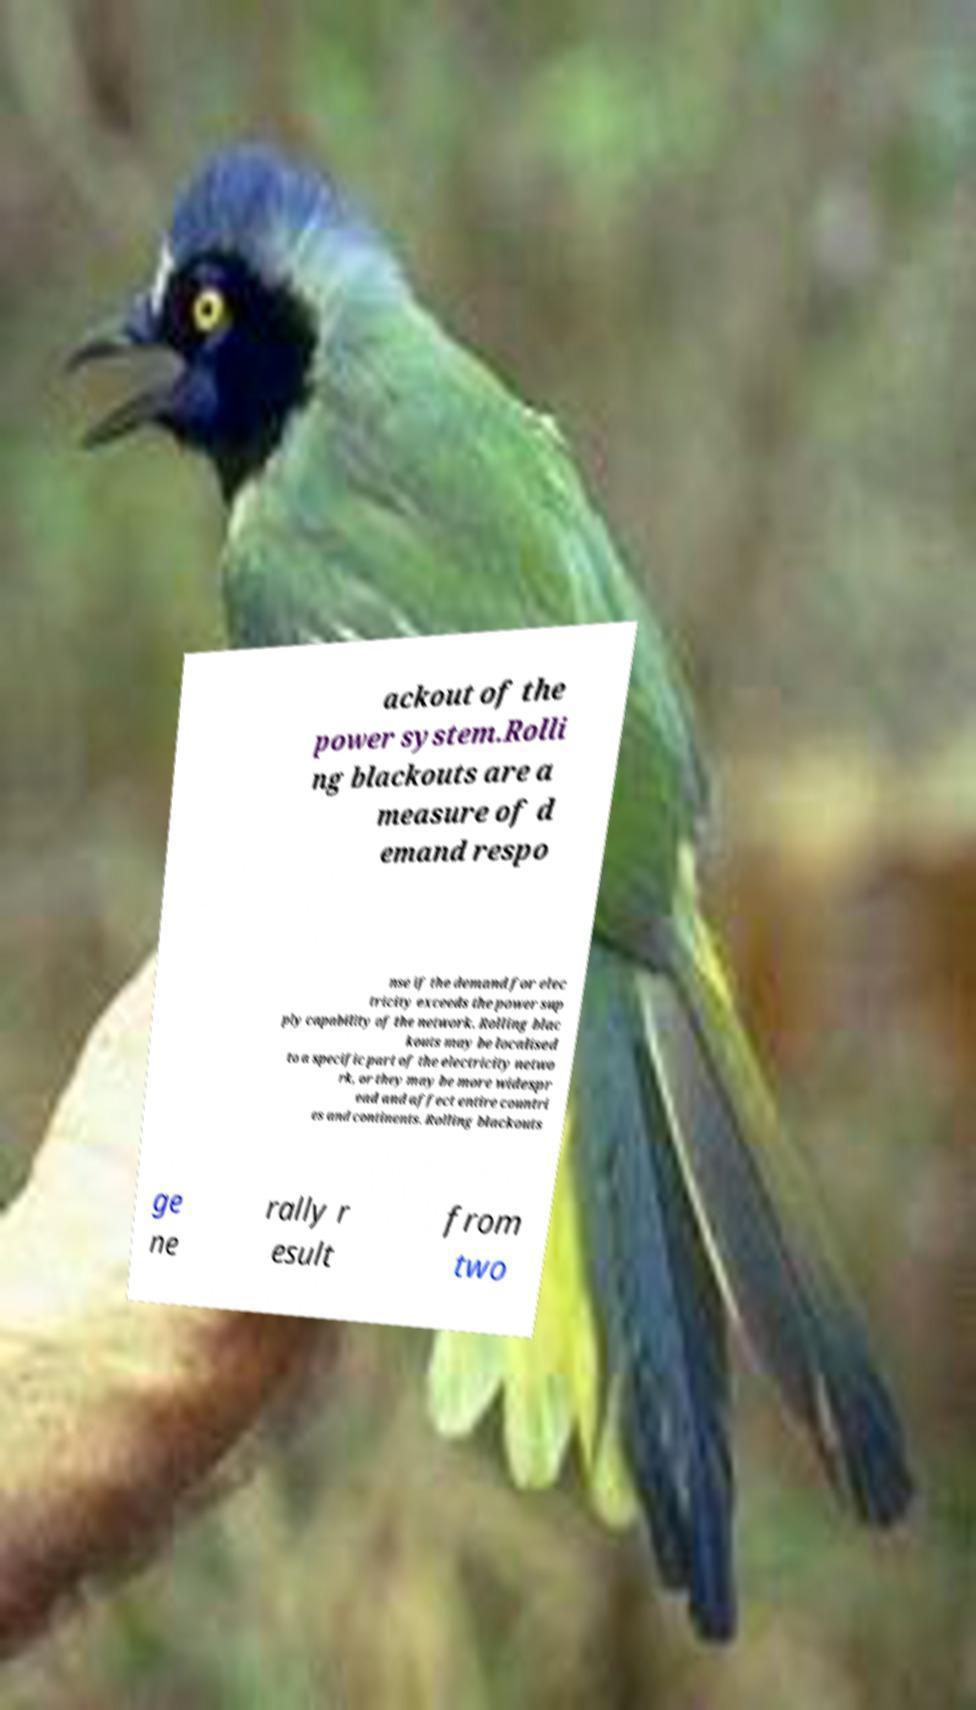For documentation purposes, I need the text within this image transcribed. Could you provide that? ackout of the power system.Rolli ng blackouts are a measure of d emand respo nse if the demand for elec tricity exceeds the power sup ply capability of the network. Rolling blac kouts may be localised to a specific part of the electricity netwo rk, or they may be more widespr ead and affect entire countri es and continents. Rolling blackouts ge ne rally r esult from two 